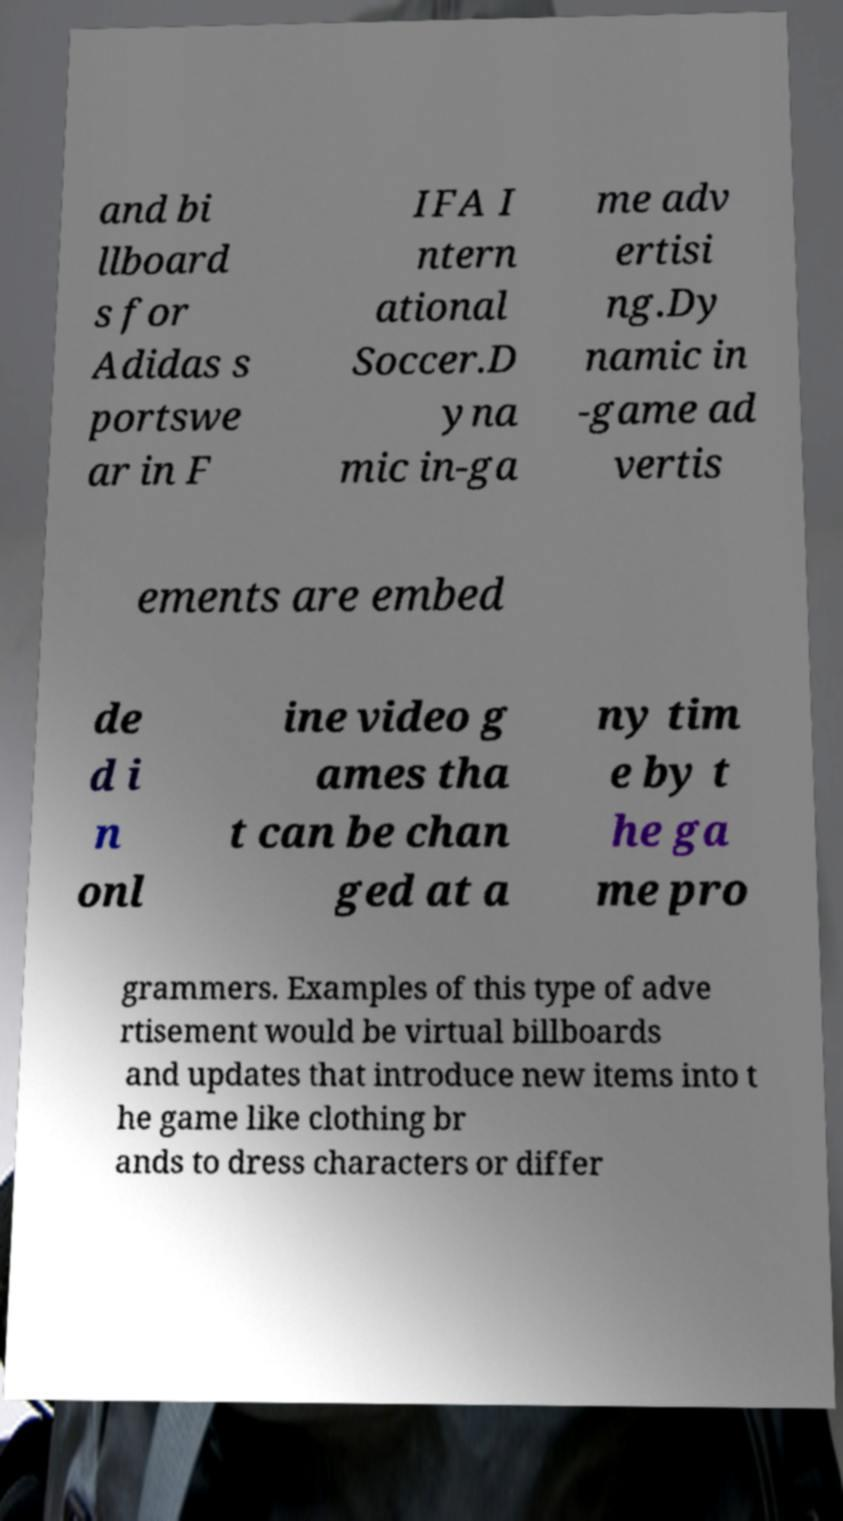Could you extract and type out the text from this image? and bi llboard s for Adidas s portswe ar in F IFA I ntern ational Soccer.D yna mic in-ga me adv ertisi ng.Dy namic in -game ad vertis ements are embed de d i n onl ine video g ames tha t can be chan ged at a ny tim e by t he ga me pro grammers. Examples of this type of adve rtisement would be virtual billboards and updates that introduce new items into t he game like clothing br ands to dress characters or differ 